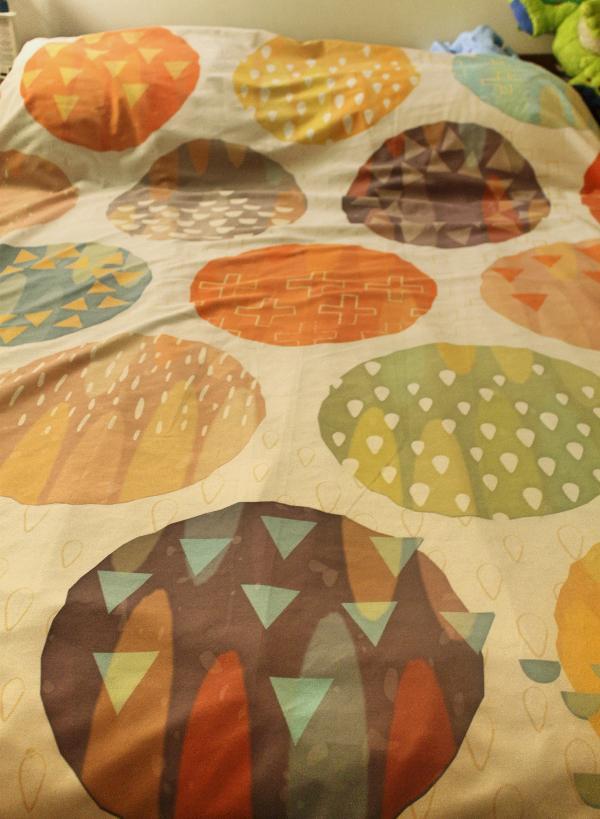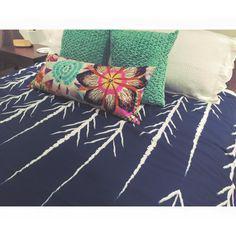The first image is the image on the left, the second image is the image on the right. For the images displayed, is the sentence "An image shows a printed bedspread with no throw pillows on top or people under it." factually correct? Answer yes or no. Yes. 